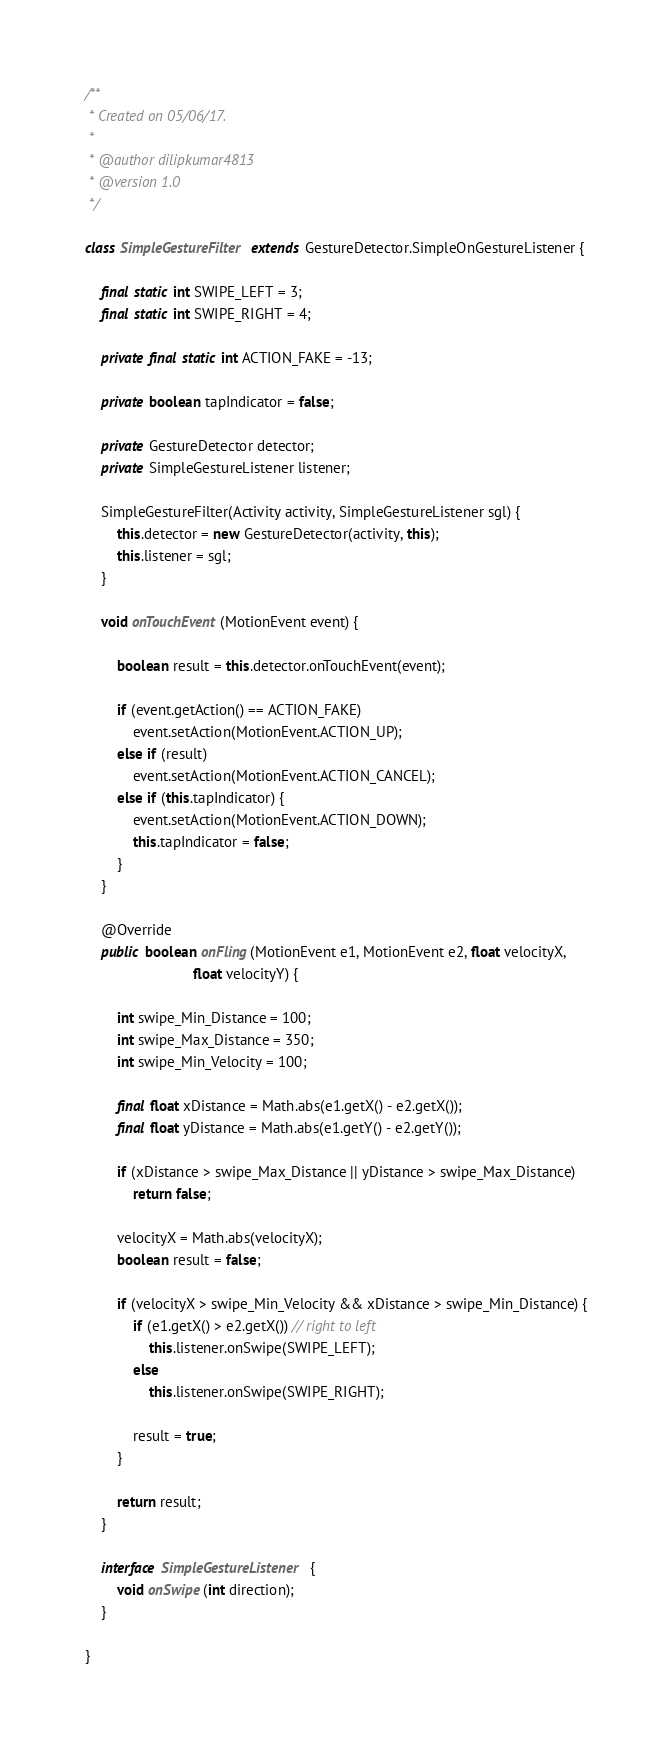Convert code to text. <code><loc_0><loc_0><loc_500><loc_500><_Java_>/**
 * Created on 05/06/17.
 *
 * @author dilipkumar4813
 * @version 1.0
 */

class SimpleGestureFilter extends GestureDetector.SimpleOnGestureListener {

    final static int SWIPE_LEFT = 3;
    final static int SWIPE_RIGHT = 4;

    private final static int ACTION_FAKE = -13;

    private boolean tapIndicator = false;

    private GestureDetector detector;
    private SimpleGestureListener listener;

    SimpleGestureFilter(Activity activity, SimpleGestureListener sgl) {
        this.detector = new GestureDetector(activity, this);
        this.listener = sgl;
    }

    void onTouchEvent(MotionEvent event) {

        boolean result = this.detector.onTouchEvent(event);

        if (event.getAction() == ACTION_FAKE)
            event.setAction(MotionEvent.ACTION_UP);
        else if (result)
            event.setAction(MotionEvent.ACTION_CANCEL);
        else if (this.tapIndicator) {
            event.setAction(MotionEvent.ACTION_DOWN);
            this.tapIndicator = false;
        }
    }

    @Override
    public boolean onFling(MotionEvent e1, MotionEvent e2, float velocityX,
                           float velocityY) {

        int swipe_Min_Distance = 100;
        int swipe_Max_Distance = 350;
        int swipe_Min_Velocity = 100;

        final float xDistance = Math.abs(e1.getX() - e2.getX());
        final float yDistance = Math.abs(e1.getY() - e2.getY());

        if (xDistance > swipe_Max_Distance || yDistance > swipe_Max_Distance)
            return false;

        velocityX = Math.abs(velocityX);
        boolean result = false;

        if (velocityX > swipe_Min_Velocity && xDistance > swipe_Min_Distance) {
            if (e1.getX() > e2.getX()) // right to left
                this.listener.onSwipe(SWIPE_LEFT);
            else
                this.listener.onSwipe(SWIPE_RIGHT);

            result = true;
        }

        return result;
    }

    interface SimpleGestureListener {
        void onSwipe(int direction);
    }

}
</code> 